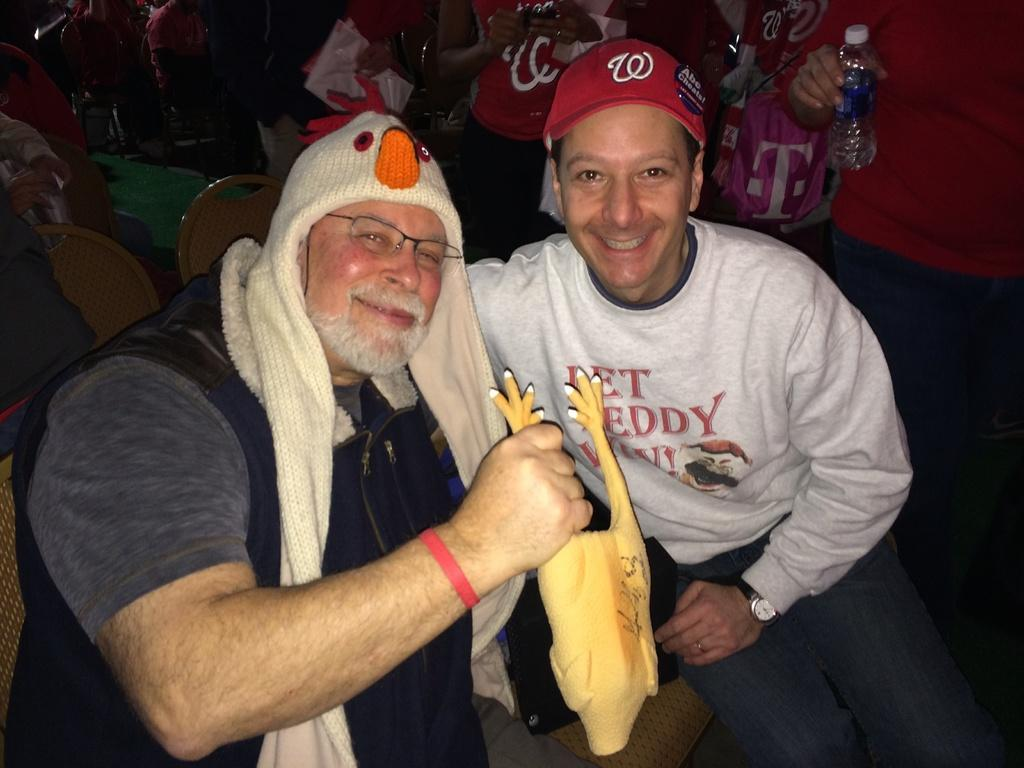Provide a one-sentence caption for the provided image. a man holding a rubber chicken is sitting beside a man with a W on his red hat. 